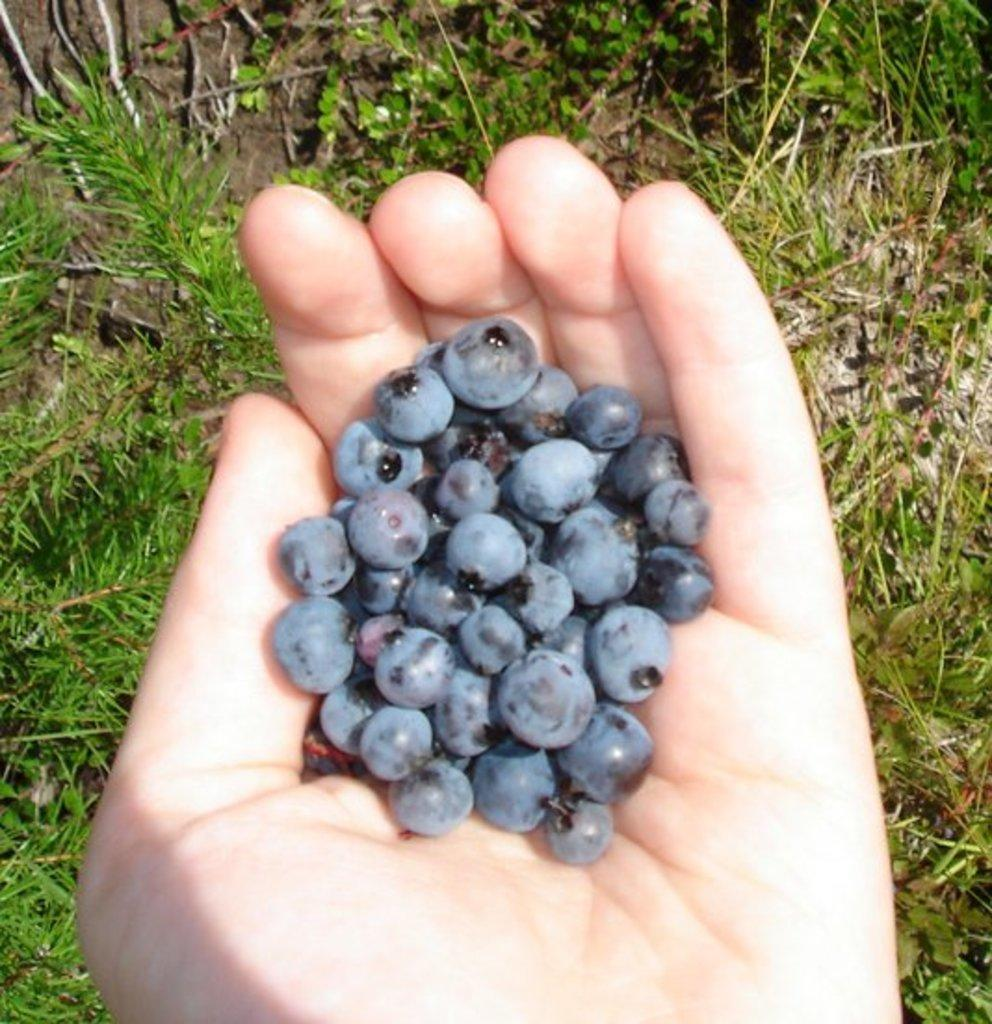What part of a person's body is visible in the image? There is a person's hand in the image. What is the person holding in the image? The person is holding grapes. What type of vegetation can be seen in the image? There are plants visible in the image. What type of books can be seen in the library in the image? There is no library present in the image, so it is not possible to determine what type of books might be seen. 